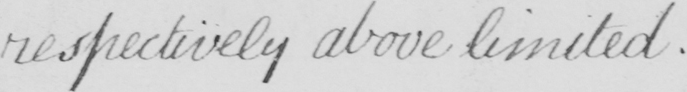What does this handwritten line say? respectively above limited . 